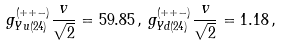Convert formula to latex. <formula><loc_0><loc_0><loc_500><loc_500>g _ { Y u ( 2 4 ) } ^ { ( + + - ) } \frac { v } { \sqrt { 2 } } = 5 9 . 8 5 \, , \, g _ { Y d ( 2 4 ) } ^ { ( + + - ) } \frac { v } { \sqrt { 2 } } = 1 . 1 8 \, ,</formula> 